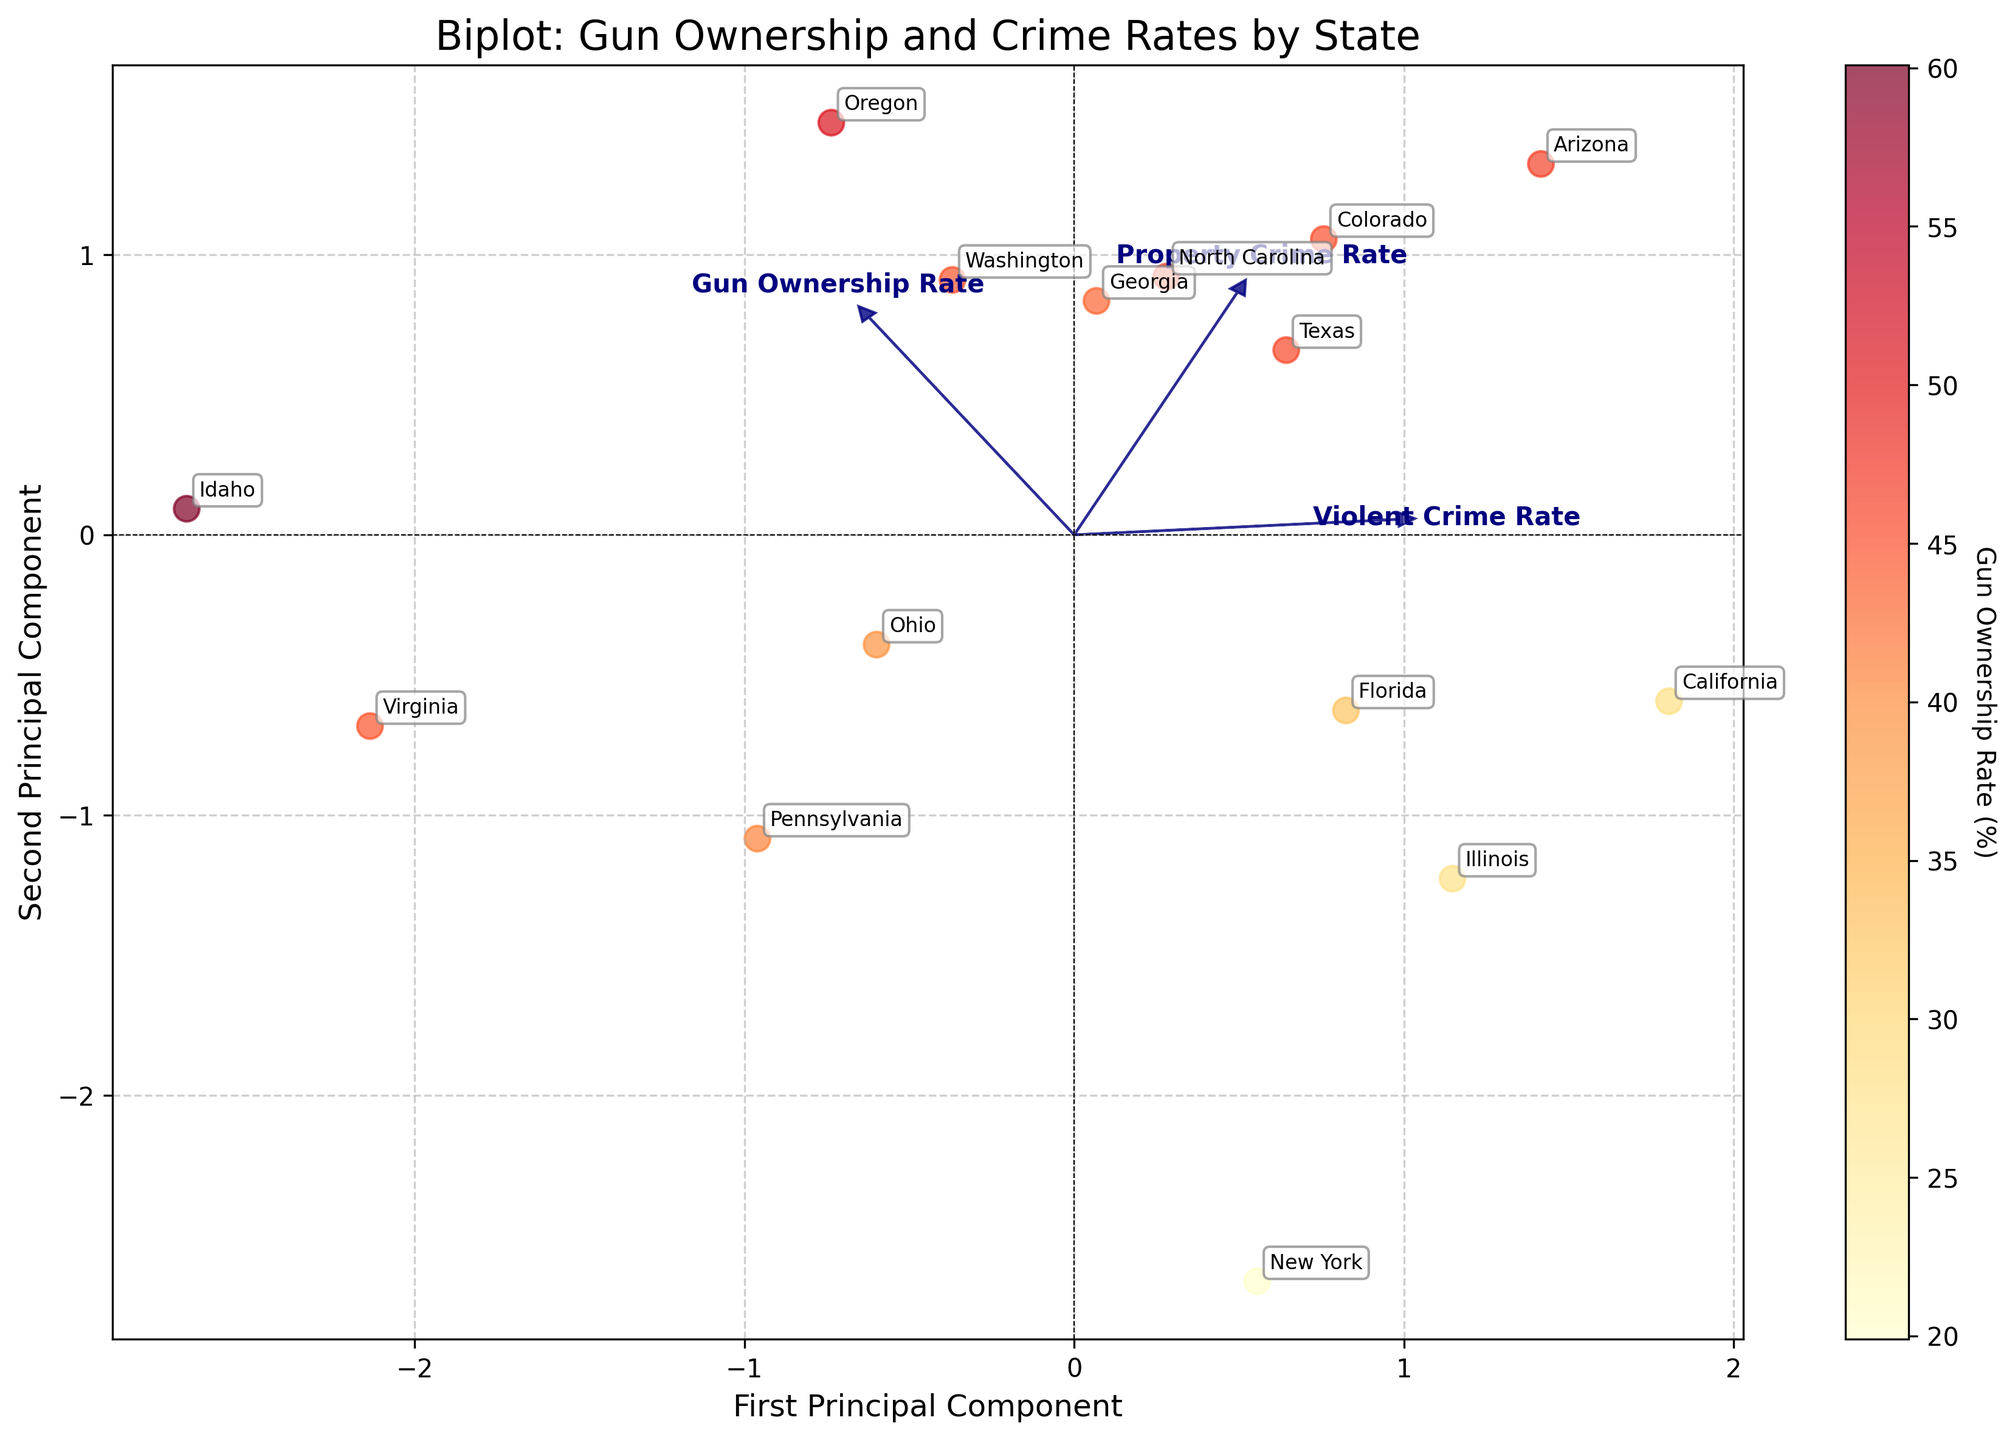What is the title of the biplot? The title is located at the top of the plot and clearly states the main focus of the visual, which is "Biplot: Gun Ownership and Crime Rates by State".
Answer: Biplot: Gun Ownership and Crime Rates by State Which feature has the longest loading vector in the biplot? The length of the loading vectors represents the importance of the features in the principal components. The feature with the longest arrow is "Property Crime Rate".
Answer: Property Crime Rate How many states have been plotted in the biplot? Each data point on the biplot represents a state, which are labeled with their names. Counting these labels will give the number of states.
Answer: 14 Which state has the highest gun ownership rate and where is it located in the biplot? The state with the highest gun ownership rate can be identified by the color gradient and cross-referencing with the data points. Idaho has the highest rate (60.1%) and can be identified by its positioning and label in the plot.
Answer: Idaho Which feature is more positively correlated with the first principal component according to the biplot? The direction and length of the loading vector relative to the first principal component axis (x-axis) indicate the correlation. "Property Crime Rate" has the most significant positive correlation with the first principal component.
Answer: Property Crime Rate What is the relationship between gun ownership rate and violent crime rate among the states? The direction and closeness of the "Gun Ownership Rate" and "Violent Crime Rate" vectors can be used to infer their relationship. The two features have relatively perpendicular vectors, suggesting little to no correlation.
Answer: No significant correlation Which state has the lowest violent crime rate and where is it located on the biplot? To find this, identify the state label closest to the lower end of the "Violent Crime Rate" vector. Virginia, with the lowest violent crime rate (208.0), can be located accordingly.
Answer: Virginia Are the vectors for "Gun Ownership Rate" and "Property Crime Rate" pointing in the same or opposite directions? By observing the directions of the vectors, we can determine their relationship. Both vectors point in roughly the same direction.
Answer: Same direction 